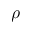<formula> <loc_0><loc_0><loc_500><loc_500>\rho</formula> 